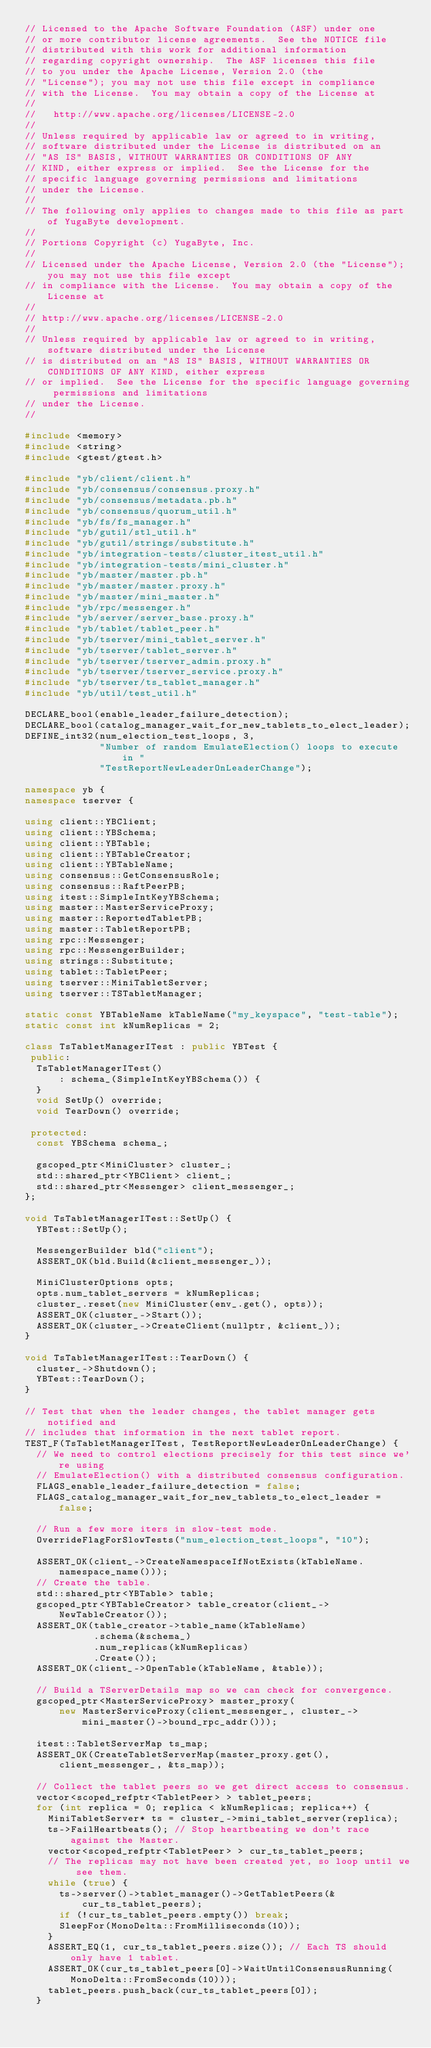<code> <loc_0><loc_0><loc_500><loc_500><_C++_>// Licensed to the Apache Software Foundation (ASF) under one
// or more contributor license agreements.  See the NOTICE file
// distributed with this work for additional information
// regarding copyright ownership.  The ASF licenses this file
// to you under the Apache License, Version 2.0 (the
// "License"); you may not use this file except in compliance
// with the License.  You may obtain a copy of the License at
//
//   http://www.apache.org/licenses/LICENSE-2.0
//
// Unless required by applicable law or agreed to in writing,
// software distributed under the License is distributed on an
// "AS IS" BASIS, WITHOUT WARRANTIES OR CONDITIONS OF ANY
// KIND, either express or implied.  See the License for the
// specific language governing permissions and limitations
// under the License.
//
// The following only applies to changes made to this file as part of YugaByte development.
//
// Portions Copyright (c) YugaByte, Inc.
//
// Licensed under the Apache License, Version 2.0 (the "License"); you may not use this file except
// in compliance with the License.  You may obtain a copy of the License at
//
// http://www.apache.org/licenses/LICENSE-2.0
//
// Unless required by applicable law or agreed to in writing, software distributed under the License
// is distributed on an "AS IS" BASIS, WITHOUT WARRANTIES OR CONDITIONS OF ANY KIND, either express
// or implied.  See the License for the specific language governing permissions and limitations
// under the License.
//

#include <memory>
#include <string>
#include <gtest/gtest.h>

#include "yb/client/client.h"
#include "yb/consensus/consensus.proxy.h"
#include "yb/consensus/metadata.pb.h"
#include "yb/consensus/quorum_util.h"
#include "yb/fs/fs_manager.h"
#include "yb/gutil/stl_util.h"
#include "yb/gutil/strings/substitute.h"
#include "yb/integration-tests/cluster_itest_util.h"
#include "yb/integration-tests/mini_cluster.h"
#include "yb/master/master.pb.h"
#include "yb/master/master.proxy.h"
#include "yb/master/mini_master.h"
#include "yb/rpc/messenger.h"
#include "yb/server/server_base.proxy.h"
#include "yb/tablet/tablet_peer.h"
#include "yb/tserver/mini_tablet_server.h"
#include "yb/tserver/tablet_server.h"
#include "yb/tserver/tserver_admin.proxy.h"
#include "yb/tserver/tserver_service.proxy.h"
#include "yb/tserver/ts_tablet_manager.h"
#include "yb/util/test_util.h"

DECLARE_bool(enable_leader_failure_detection);
DECLARE_bool(catalog_manager_wait_for_new_tablets_to_elect_leader);
DEFINE_int32(num_election_test_loops, 3,
             "Number of random EmulateElection() loops to execute in "
             "TestReportNewLeaderOnLeaderChange");

namespace yb {
namespace tserver {

using client::YBClient;
using client::YBSchema;
using client::YBTable;
using client::YBTableCreator;
using client::YBTableName;
using consensus::GetConsensusRole;
using consensus::RaftPeerPB;
using itest::SimpleIntKeyYBSchema;
using master::MasterServiceProxy;
using master::ReportedTabletPB;
using master::TabletReportPB;
using rpc::Messenger;
using rpc::MessengerBuilder;
using strings::Substitute;
using tablet::TabletPeer;
using tserver::MiniTabletServer;
using tserver::TSTabletManager;

static const YBTableName kTableName("my_keyspace", "test-table");
static const int kNumReplicas = 2;

class TsTabletManagerITest : public YBTest {
 public:
  TsTabletManagerITest()
      : schema_(SimpleIntKeyYBSchema()) {
  }
  void SetUp() override;
  void TearDown() override;

 protected:
  const YBSchema schema_;

  gscoped_ptr<MiniCluster> cluster_;
  std::shared_ptr<YBClient> client_;
  std::shared_ptr<Messenger> client_messenger_;
};

void TsTabletManagerITest::SetUp() {
  YBTest::SetUp();

  MessengerBuilder bld("client");
  ASSERT_OK(bld.Build(&client_messenger_));

  MiniClusterOptions opts;
  opts.num_tablet_servers = kNumReplicas;
  cluster_.reset(new MiniCluster(env_.get(), opts));
  ASSERT_OK(cluster_->Start());
  ASSERT_OK(cluster_->CreateClient(nullptr, &client_));
}

void TsTabletManagerITest::TearDown() {
  cluster_->Shutdown();
  YBTest::TearDown();
}

// Test that when the leader changes, the tablet manager gets notified and
// includes that information in the next tablet report.
TEST_F(TsTabletManagerITest, TestReportNewLeaderOnLeaderChange) {
  // We need to control elections precisely for this test since we're using
  // EmulateElection() with a distributed consensus configuration.
  FLAGS_enable_leader_failure_detection = false;
  FLAGS_catalog_manager_wait_for_new_tablets_to_elect_leader = false;

  // Run a few more iters in slow-test mode.
  OverrideFlagForSlowTests("num_election_test_loops", "10");

  ASSERT_OK(client_->CreateNamespaceIfNotExists(kTableName.namespace_name()));
  // Create the table.
  std::shared_ptr<YBTable> table;
  gscoped_ptr<YBTableCreator> table_creator(client_->NewTableCreator());
  ASSERT_OK(table_creator->table_name(kTableName)
            .schema(&schema_)
            .num_replicas(kNumReplicas)
            .Create());
  ASSERT_OK(client_->OpenTable(kTableName, &table));

  // Build a TServerDetails map so we can check for convergence.
  gscoped_ptr<MasterServiceProxy> master_proxy(
      new MasterServiceProxy(client_messenger_, cluster_->mini_master()->bound_rpc_addr()));

  itest::TabletServerMap ts_map;
  ASSERT_OK(CreateTabletServerMap(master_proxy.get(), client_messenger_, &ts_map));

  // Collect the tablet peers so we get direct access to consensus.
  vector<scoped_refptr<TabletPeer> > tablet_peers;
  for (int replica = 0; replica < kNumReplicas; replica++) {
    MiniTabletServer* ts = cluster_->mini_tablet_server(replica);
    ts->FailHeartbeats(); // Stop heartbeating we don't race against the Master.
    vector<scoped_refptr<TabletPeer> > cur_ts_tablet_peers;
    // The replicas may not have been created yet, so loop until we see them.
    while (true) {
      ts->server()->tablet_manager()->GetTabletPeers(&cur_ts_tablet_peers);
      if (!cur_ts_tablet_peers.empty()) break;
      SleepFor(MonoDelta::FromMilliseconds(10));
    }
    ASSERT_EQ(1, cur_ts_tablet_peers.size()); // Each TS should only have 1 tablet.
    ASSERT_OK(cur_ts_tablet_peers[0]->WaitUntilConsensusRunning(MonoDelta::FromSeconds(10)));
    tablet_peers.push_back(cur_ts_tablet_peers[0]);
  }
</code> 